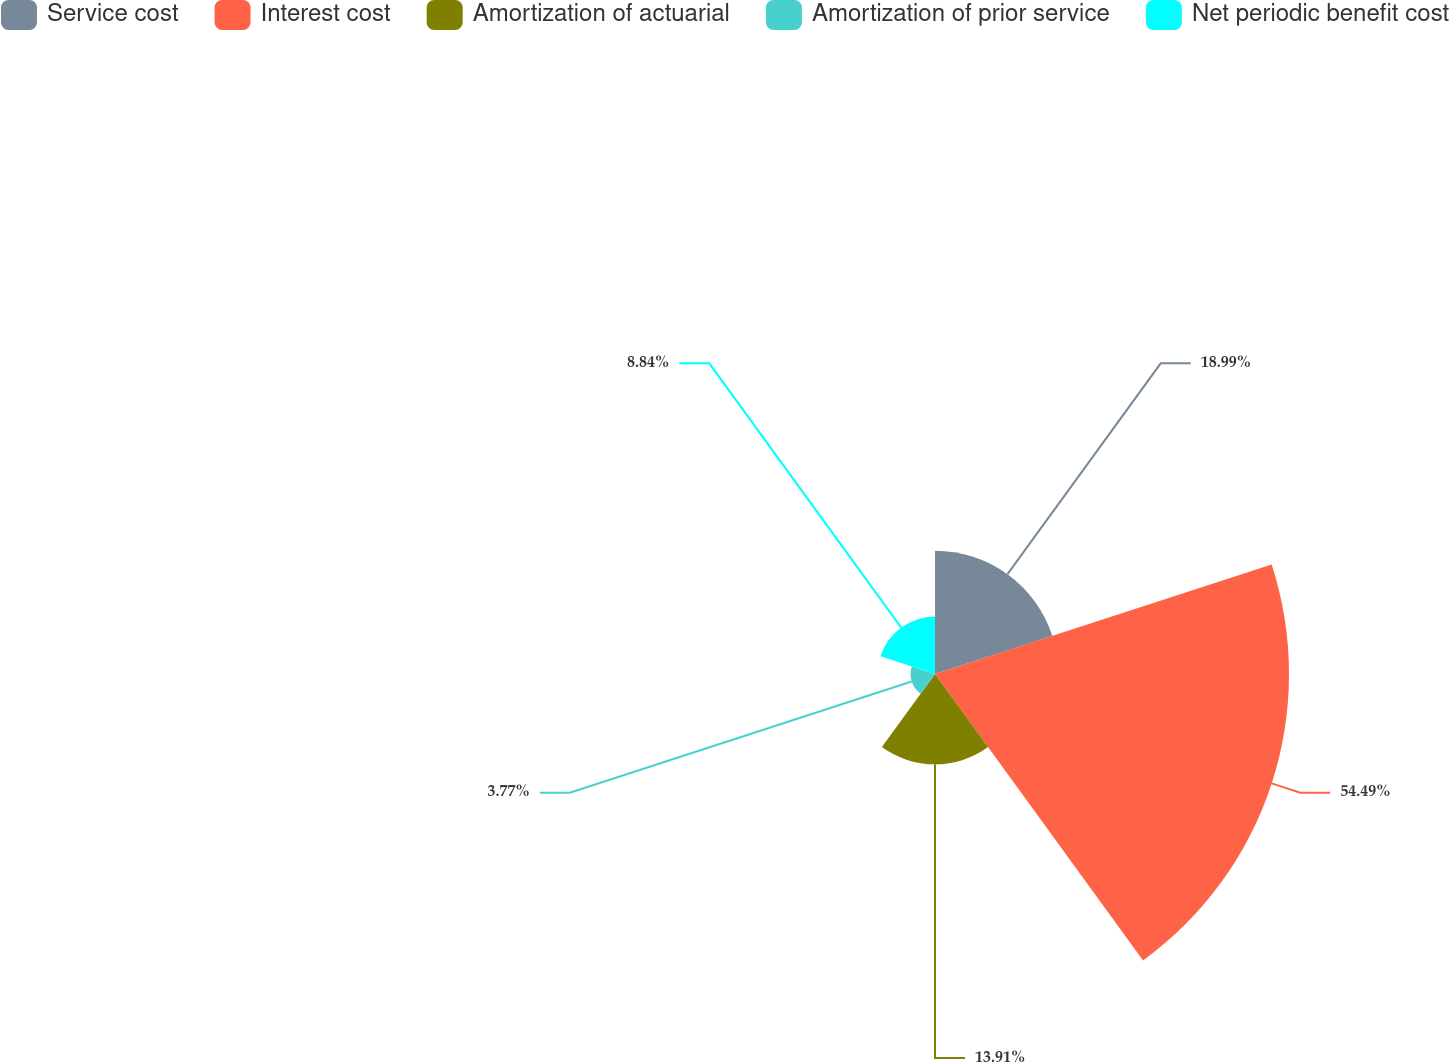<chart> <loc_0><loc_0><loc_500><loc_500><pie_chart><fcel>Service cost<fcel>Interest cost<fcel>Amortization of actuarial<fcel>Amortization of prior service<fcel>Net periodic benefit cost<nl><fcel>18.99%<fcel>54.5%<fcel>13.91%<fcel>3.77%<fcel>8.84%<nl></chart> 